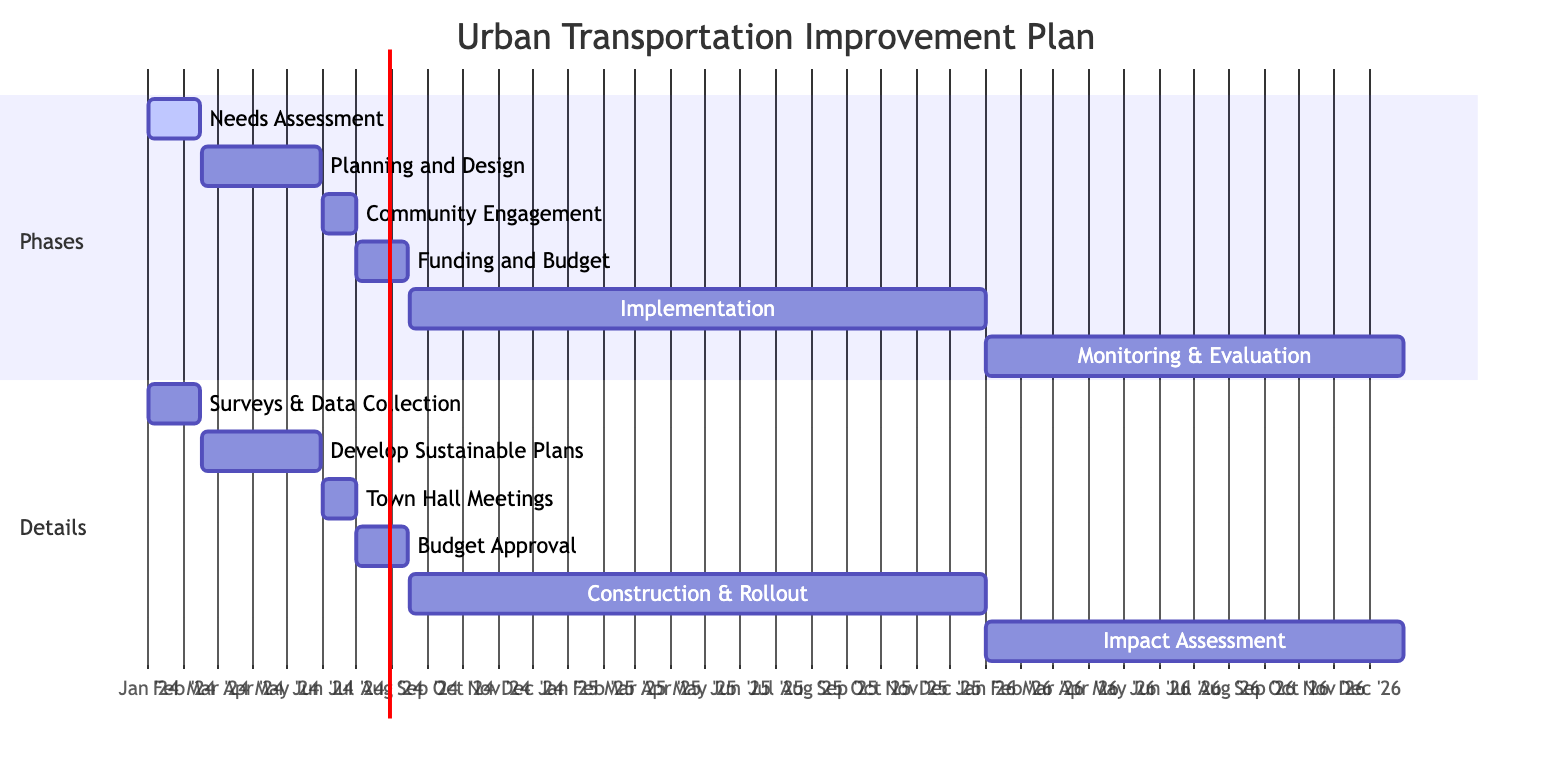What is the duration of the Needs Assessment phase? The Needs Assessment phase starts on January 1, 2024, and ends on February 15, 2024. Calculating the duration, there are 45 days between these dates.
Answer: 45 days What comes immediately after Planning and Design? The Planning and Design phase ends on May 30, 2024, and the next phase, Community Engagement, starts on June 1, 2024. So, Community Engagement comes immediately after Planning and Design.
Answer: Community Engagement How many phases are included in the Urban Transportation Improvement Plan? The diagram lists six distinct phases: Needs Assessment, Planning and Design, Community Engagement, Funding and Budget Approval, Implementation, and Monitoring and Evaluation. Counting them gives a total of six phases.
Answer: 6 phases What is the total time span for the Implementation phase? The Implementation phase starts on August 16, 2024, and runs through December 31, 2025. The duration can be calculated from August 16, 2024, to December 31, 2025, which is 1 year and approximately 4.5 months, totaling 16.5 months.
Answer: 16.5 months Which phase has the longest duration? Implementation phase starts on August 16, 2024, and ends on December 31, 2025, making it 16.5 months long. That is longer than any other phase in the diagram.
Answer: Implementation What is the starting date of the Community Engagement phase? According to the diagram, the Community Engagement phase begins on June 1, 2024. This is directly stated in the timeline for that phase.
Answer: June 1, 2024 What is the last phase of the Urban Transportation Improvement Plan? The diagram shows that the last phase is Monitoring and Evaluation, which starts on January 1, 2026, and ends on December 31, 2026. This is the final phase in the timeline.
Answer: Monitoring and Evaluation Which phases are included in the year 2024? Reviewing the timeline for the year 2024, the phases included are Needs Assessment, Planning and Design, Community Engagement, and Funding and Budget Approval, all of which fall within that year.
Answer: 4 phases How long does the Monitoring and Evaluation phase last? The Monitoring and Evaluation phase runs from January 1, 2026, to December 31, 2026. The total duration is exactly one year.
Answer: 1 year 